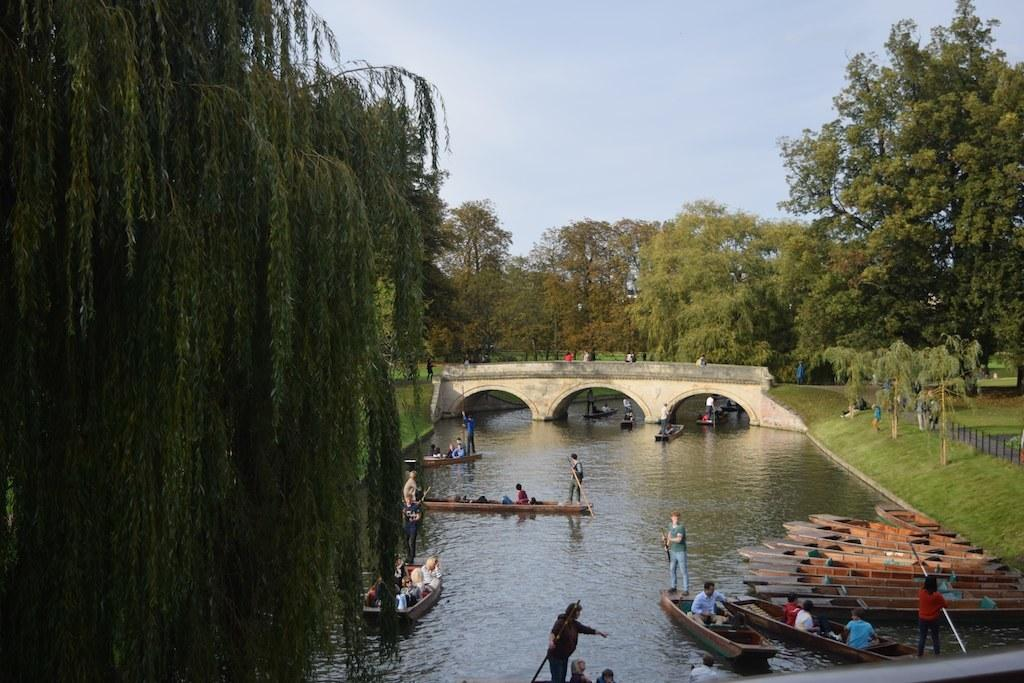Who or what can be seen in the image? There are people in the image. What are the people doing or interacting with in the image? The people are near boats on water in the image. What structures are present in the image? There is a bridge in the image. What type of natural environment is visible in the image? There are trees and grass in the image. What is visible in the background of the image? The sky is visible in the image. What type of crime is being committed in the image? There is no indication of any crime being committed in the image. --- Facts: 1. There is a person in the image. 2. The person is wearing a hat. 3. The person is holding a book. 4. The person is sitting on a bench. 5. There is a tree in the background. 6. The sky is visible in the image. Absurd Topics: unicorn, magic wand, invisible ink Conversation: Who or what can be seen in the image? There is a person in the image. What is the person wearing in the image? The person is wearing a hat in the image. What is the person holding in the image? The person is holding a book in the image. What is the person doing in the image? The person is sitting on a bench in the image. What type of natural environment is visible in the image? There is a tree in the background in the image. What is visible in the background of the image? The sky is visible in the image. Reasoning: Let's think step by step in order to produce the conversation. We start by identifying the main subject in the image, which is the person. Then, we describe specific details about the person, such as the hat and the book they are holding. Next, we observe the person's actions, noting that they are sitting on a bench. Finally, we describe the natural setting visible in the image, which includes a tree in the background. We also mention the sky visible in the background of the image. Absurd Question/Answer: What type of unicorn can be seen playing with a magic wand in the image? There is no unicorn or magic wand present in the image. --- Facts: 1. There is a group of people in the image. 2. The people are wearing matching outfits. 3. The people are standing in a line. 4. There is a banner with text in the image. 5. The banner is hanging above the people. Absurd Topics: giant robot, flying saucers, teleportation device Conversation: Who or what can be seen in the image? There is a group of people in the image. What are the people wearing in the image? The people are wearing matching outfits in the image. 